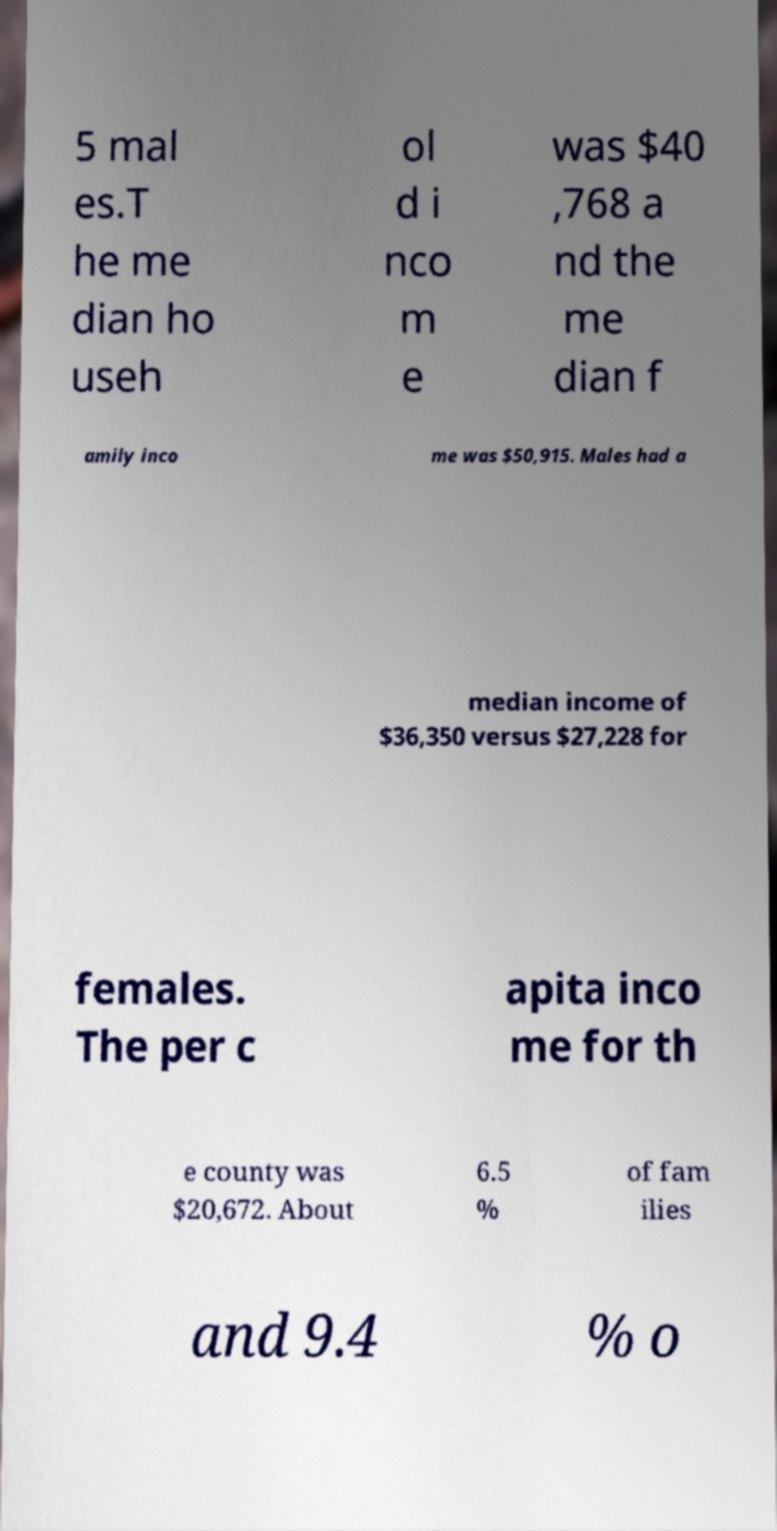I need the written content from this picture converted into text. Can you do that? 5 mal es.T he me dian ho useh ol d i nco m e was $40 ,768 a nd the me dian f amily inco me was $50,915. Males had a median income of $36,350 versus $27,228 for females. The per c apita inco me for th e county was $20,672. About 6.5 % of fam ilies and 9.4 % o 